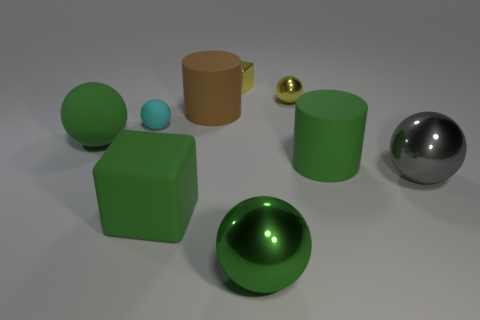Can you tell me about the material properties and possible uses for the green objects depicted in the image? Certainly! The larger green sphere and the cube both have a highly polished finish, suggesting that they are made of a material like polished stone or coated metal. Such materials could be used in decorative items or in architectural design elements for their aesthetic appeal and durability.  Could you suggest a real-world setting where these objects might be found? These objects could be part of a modern art installation or found in an educational setting like a science museum, where they might be used to demonstrate principles of geometry, materials science, or optics. 